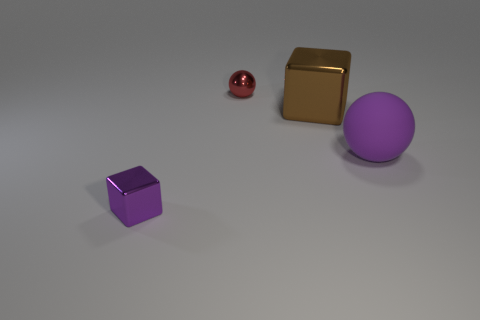Add 2 red objects. How many objects exist? 6 Add 1 large green matte blocks. How many large green matte blocks exist? 1 Subtract 0 yellow blocks. How many objects are left? 4 Subtract all blocks. Subtract all red things. How many objects are left? 1 Add 2 balls. How many balls are left? 4 